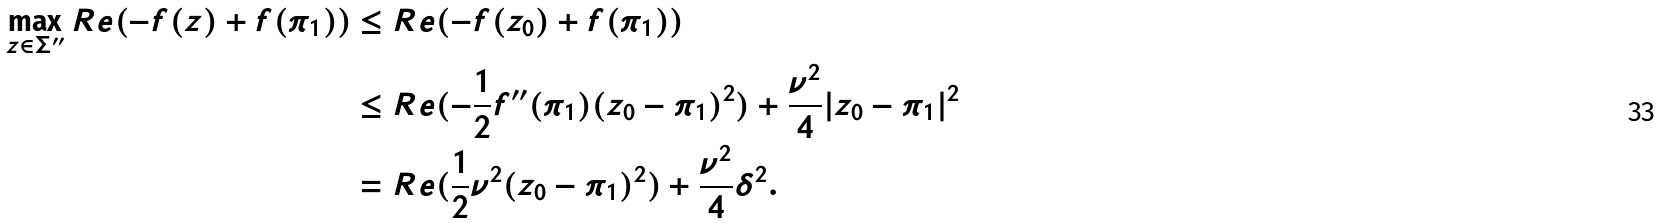Convert formula to latex. <formula><loc_0><loc_0><loc_500><loc_500>\max _ { z \in \Sigma ^ { \prime \prime } } R e ( - f ( z ) + f ( \pi _ { 1 } ) ) & \leq R e ( - f ( z _ { 0 } ) + f ( \pi _ { 1 } ) ) \\ & \leq R e ( - \frac { 1 } { 2 } f ^ { \prime \prime } ( \pi _ { 1 } ) ( z _ { 0 } - \pi _ { 1 } ) ^ { 2 } ) + \frac { \nu ^ { 2 } } 4 | z _ { 0 } - \pi _ { 1 } | ^ { 2 } \\ & = R e ( \frac { 1 } { 2 } \nu ^ { 2 } ( z _ { 0 } - \pi _ { 1 } ) ^ { 2 } ) + \frac { \nu ^ { 2 } } 4 \delta ^ { 2 } .</formula> 